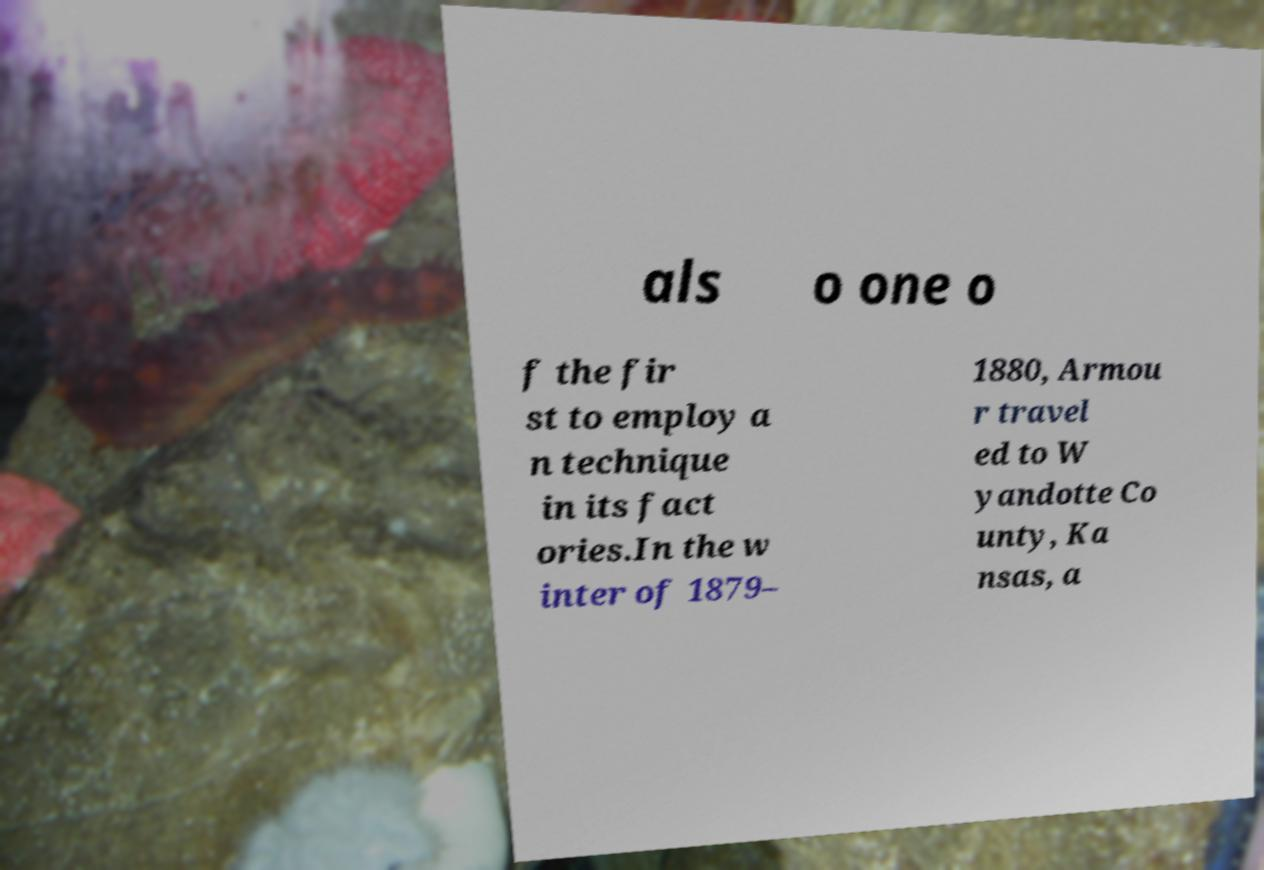Could you assist in decoding the text presented in this image and type it out clearly? als o one o f the fir st to employ a n technique in its fact ories.In the w inter of 1879– 1880, Armou r travel ed to W yandotte Co unty, Ka nsas, a 